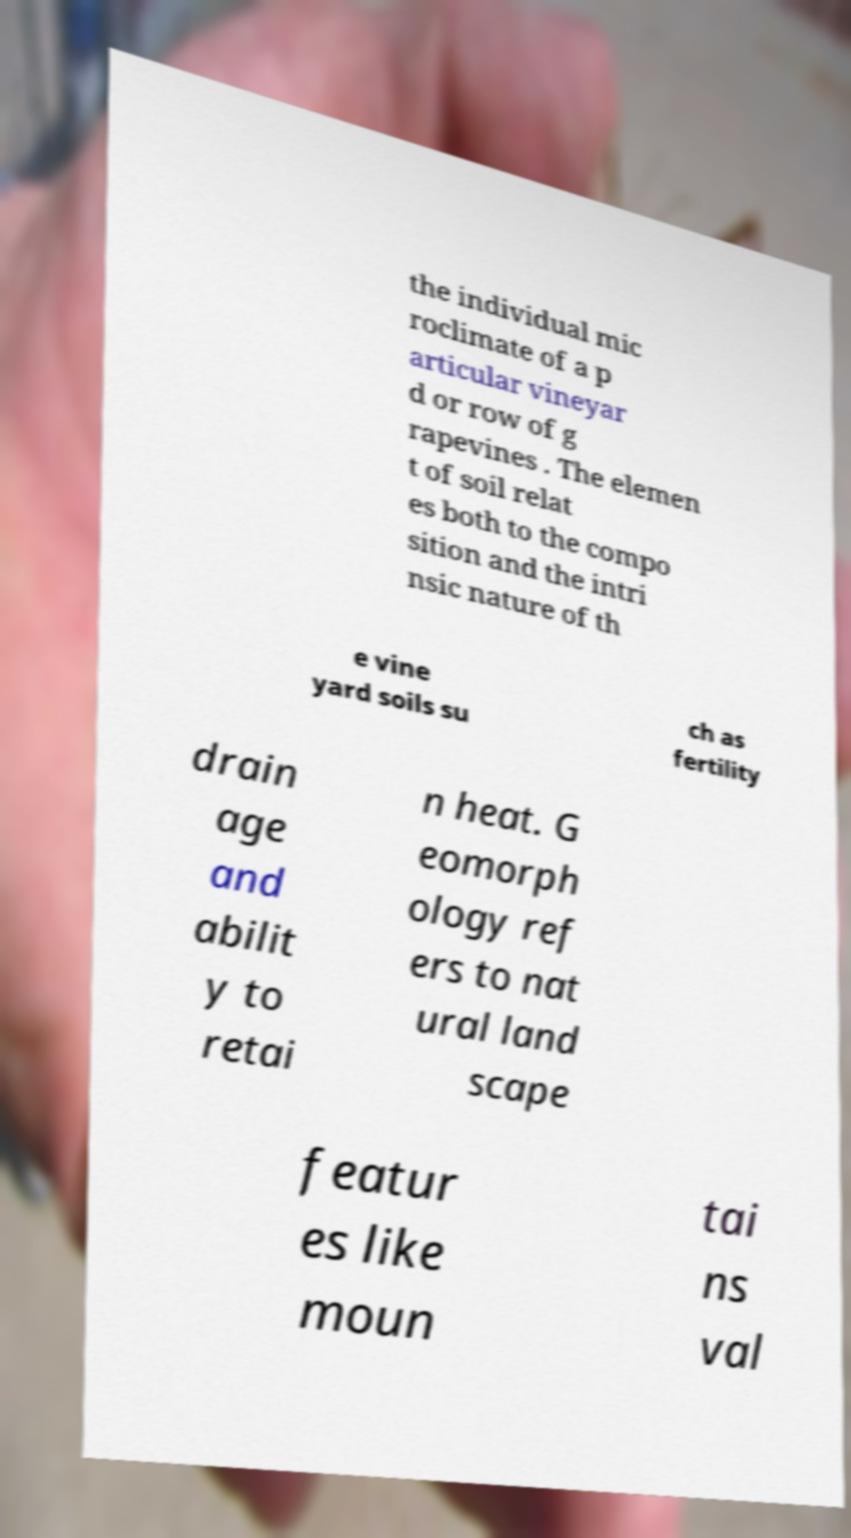There's text embedded in this image that I need extracted. Can you transcribe it verbatim? the individual mic roclimate of a p articular vineyar d or row of g rapevines . The elemen t of soil relat es both to the compo sition and the intri nsic nature of th e vine yard soils su ch as fertility drain age and abilit y to retai n heat. G eomorph ology ref ers to nat ural land scape featur es like moun tai ns val 